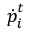<formula> <loc_0><loc_0><loc_500><loc_500>\dot { p } _ { i } ^ { t }</formula> 